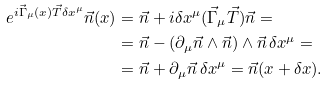Convert formula to latex. <formula><loc_0><loc_0><loc_500><loc_500>e ^ { i { \vec { \Gamma } } _ { \mu } ( x ) \vec { T } \delta x ^ { \mu } } \vec { n } ( x ) & = \vec { n } + i \delta x ^ { \mu } ( \vec { \Gamma } _ { \mu } \vec { T } ) \vec { n } = \\ & = \vec { n } - ( \partial _ { \mu } \vec { n } \wedge \vec { n } ) \wedge \vec { n } \, \delta x ^ { \mu } = \\ & = \vec { n } + \partial _ { \mu } \vec { n } \, \delta x ^ { \mu } = \vec { n } ( x + \delta x ) .</formula> 